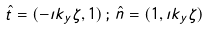Convert formula to latex. <formula><loc_0><loc_0><loc_500><loc_500>\hat { t } = ( - \imath k _ { y } \zeta , 1 ) \, ; \, \hat { n } = ( 1 , \imath k _ { y } \zeta )</formula> 